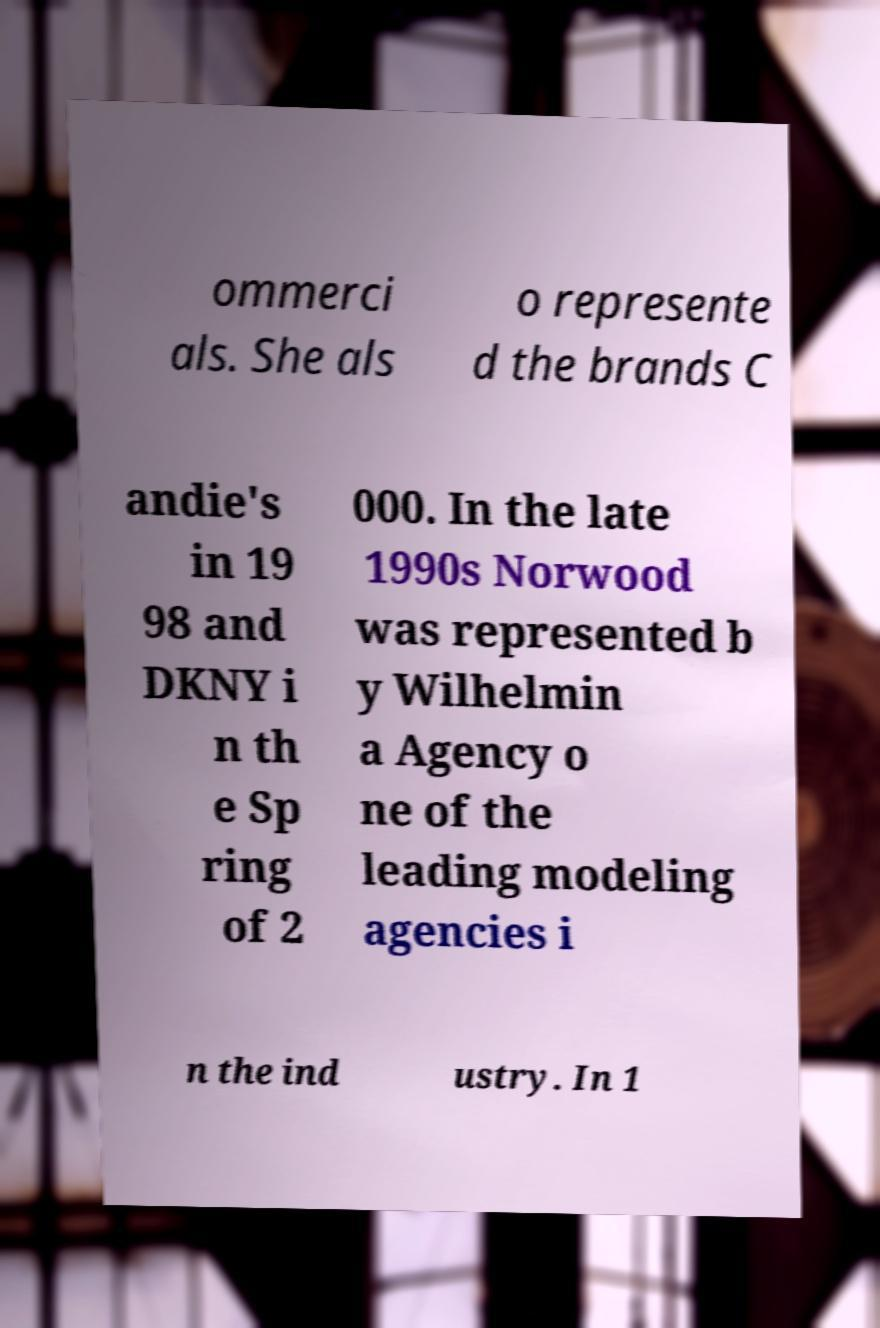I need the written content from this picture converted into text. Can you do that? ommerci als. She als o represente d the brands C andie's in 19 98 and DKNY i n th e Sp ring of 2 000. In the late 1990s Norwood was represented b y Wilhelmin a Agency o ne of the leading modeling agencies i n the ind ustry. In 1 